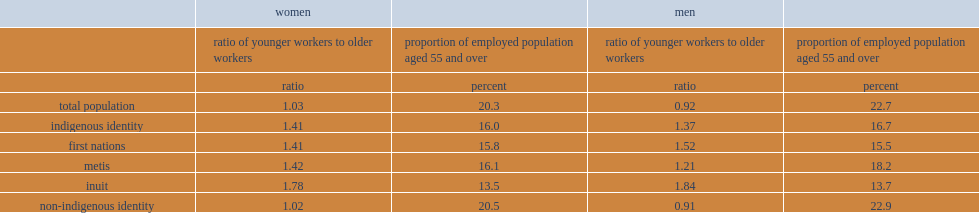Overall, what was the proportion of employed indigenous women that were aged 55 and over in 2016? 16. Overall, what was the renewal ratio of employed indigenous women that were aged 55 and over in 2016? 1.41. Which type of employed women were the youngest among the indigenous groups? Inuit. What was the proportion of employed women that were aged 55 and over? 13.5. What was the renewal ratio of inuit employed women workers? 1.78. 